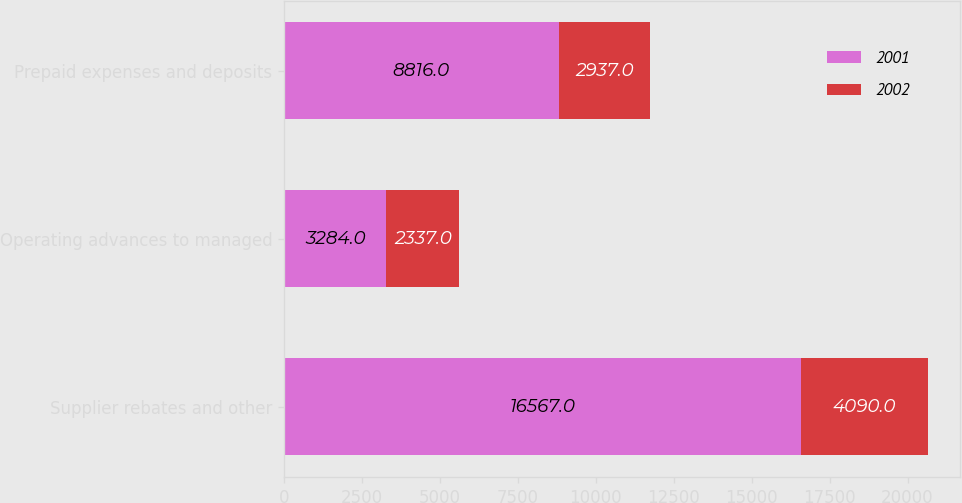Convert chart. <chart><loc_0><loc_0><loc_500><loc_500><stacked_bar_chart><ecel><fcel>Supplier rebates and other<fcel>Operating advances to managed<fcel>Prepaid expenses and deposits<nl><fcel>2001<fcel>16567<fcel>3284<fcel>8816<nl><fcel>2002<fcel>4090<fcel>2337<fcel>2937<nl></chart> 